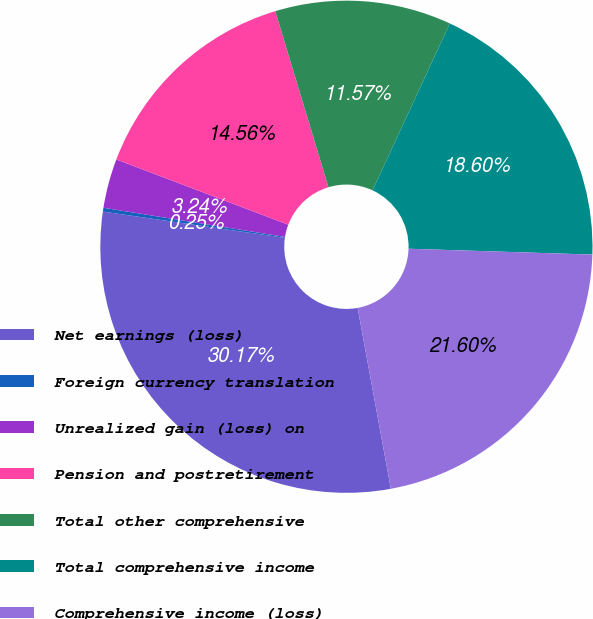Convert chart. <chart><loc_0><loc_0><loc_500><loc_500><pie_chart><fcel>Net earnings (loss)<fcel>Foreign currency translation<fcel>Unrealized gain (loss) on<fcel>Pension and postretirement<fcel>Total other comprehensive<fcel>Total comprehensive income<fcel>Comprehensive income (loss)<nl><fcel>30.17%<fcel>0.25%<fcel>3.24%<fcel>14.56%<fcel>11.57%<fcel>18.6%<fcel>21.6%<nl></chart> 